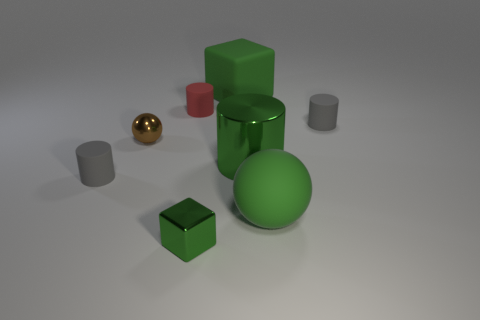Are any balls visible?
Your answer should be compact. Yes. Does the large metal cylinder have the same color as the tiny shiny sphere?
Your answer should be very brief. No. How many tiny things are either cubes or green metal spheres?
Give a very brief answer. 1. Are there any other things that have the same color as the small ball?
Provide a succinct answer. No. The large thing that is made of the same material as the tiny brown thing is what shape?
Keep it short and to the point. Cylinder. There is a green cylinder in front of the big green cube; what is its size?
Offer a very short reply. Large. The big metal object is what shape?
Your answer should be very brief. Cylinder. Does the green shiny thing that is behind the small green metallic object have the same size as the matte cylinder that is on the right side of the large matte block?
Make the answer very short. No. There is a gray thing that is on the right side of the gray cylinder in front of the gray thing right of the small red cylinder; what size is it?
Offer a terse response. Small. What is the shape of the big metallic object in front of the tiny object that is behind the matte cylinder to the right of the tiny green metal thing?
Your answer should be compact. Cylinder. 